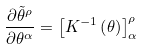<formula> <loc_0><loc_0><loc_500><loc_500>\frac { \partial \tilde { \theta } ^ { \rho } } { \partial \theta ^ { \alpha } } = \left [ K ^ { - 1 } \left ( \theta \right ) \right ] ^ { \rho } _ { \alpha }</formula> 